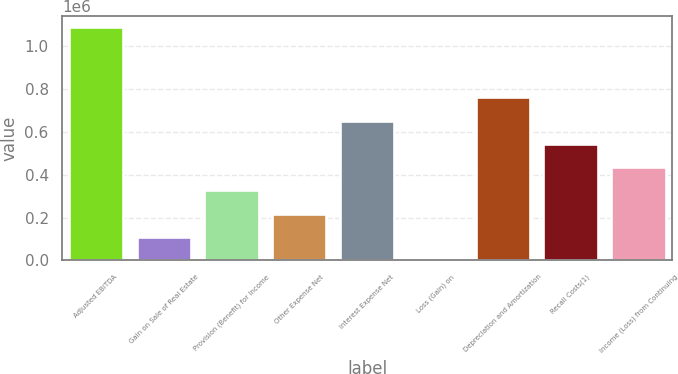Convert chart. <chart><loc_0><loc_0><loc_500><loc_500><bar_chart><fcel>Adjusted EBITDA<fcel>Gain on Sale of Real Estate<fcel>Provision (Benefit) for Income<fcel>Other Expense Net<fcel>Interest Expense Net<fcel>Loss (Gain) on<fcel>Depreciation and Amortization<fcel>Recall Costs(1)<fcel>Income (Loss) from Continuing<nl><fcel>1.08729e+06<fcel>110000<fcel>327175<fcel>218587<fcel>652938<fcel>1412<fcel>761525<fcel>544350<fcel>435762<nl></chart> 